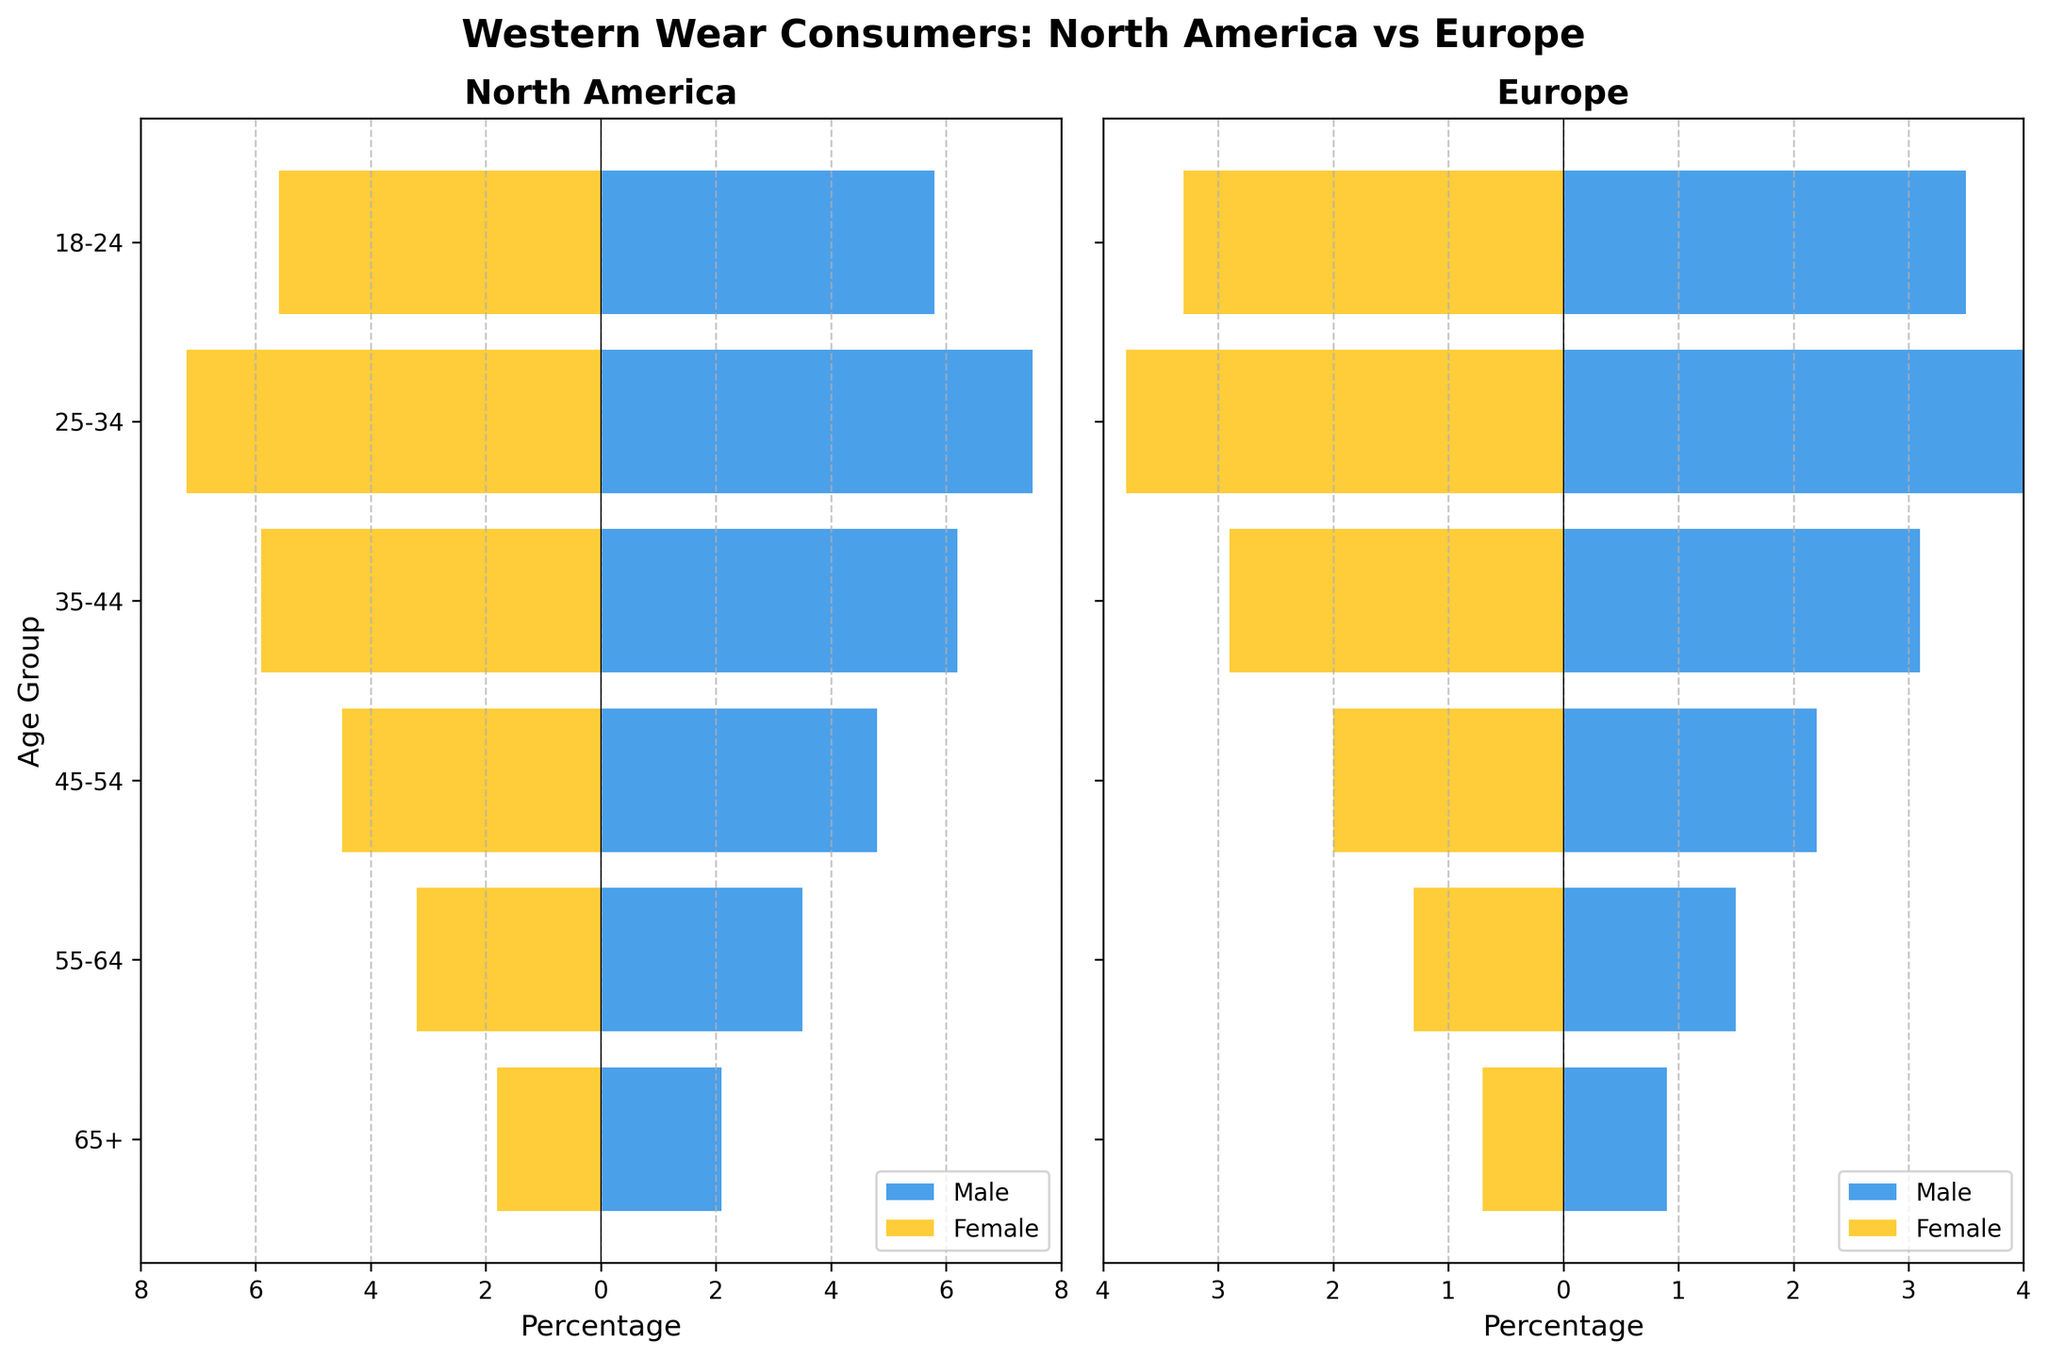Which age group has the highest percentage of Western wear consumers in North America? Look at the bars for North America in both Male and Female categories. The age group 25-34 has the tallest bars, indicating the highest percentage.
Answer: 25-34 Which region has a higher percentage of male Western wear consumers in the age group 55-64? Compare the length of the bars for males in the age group 55-64 for both regions. North America's bar for males is longer than Europe's.
Answer: North America In which age group do female consumers make up a higher percentage in Europe compared to North America? Compare the female bars across all age groups in both regions. The only group where the female bar in Europe is taller than North America's is 18-24.
Answer: 18-24 What is the total percentage of Western wear consumers aged 35-44 in Europe? Add the percentages for males and females in the 35-44 age group for Europe: 3.1% + 2.9%.
Answer: 6.0% In North America, which gender has a higher percentage of Western wear consumers aged 65+? Compare the bars for males and females in the 65+ age group in North America. The male bar is longer than the female bar.
Answer: Male Which age group has the least percentage of Western wear consumers in Europe? Look for the shortest bars in both Male and Female categories in Europe. The age group with the smallest total bar lengths is 65+.
Answer: 65+ What is the difference in percentage points between male and female Western wear consumers aged 18-24 in North America? Subtract the percentage of females from the percentage of males in the 18-24 age group for North America: 5.8% - 5.6%.
Answer: 0.2% How does the percentage of Western wear consumers aged 45-54 differ between North America and Europe? Compare the combined percentages of males and females in the 45-54 age group for both regions. North America has higher percentages (4.8% + 4.5%) compared to Europe (2.2% + 2.0%).
Answer: Higher in North America 